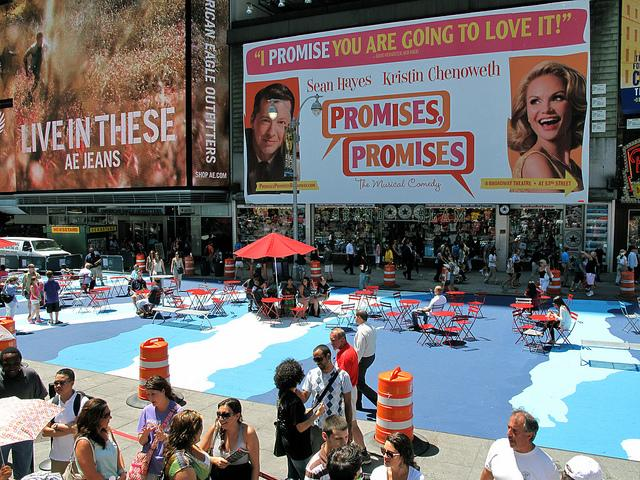What type traffic is allowed to go through this street at this time? pedestrian 